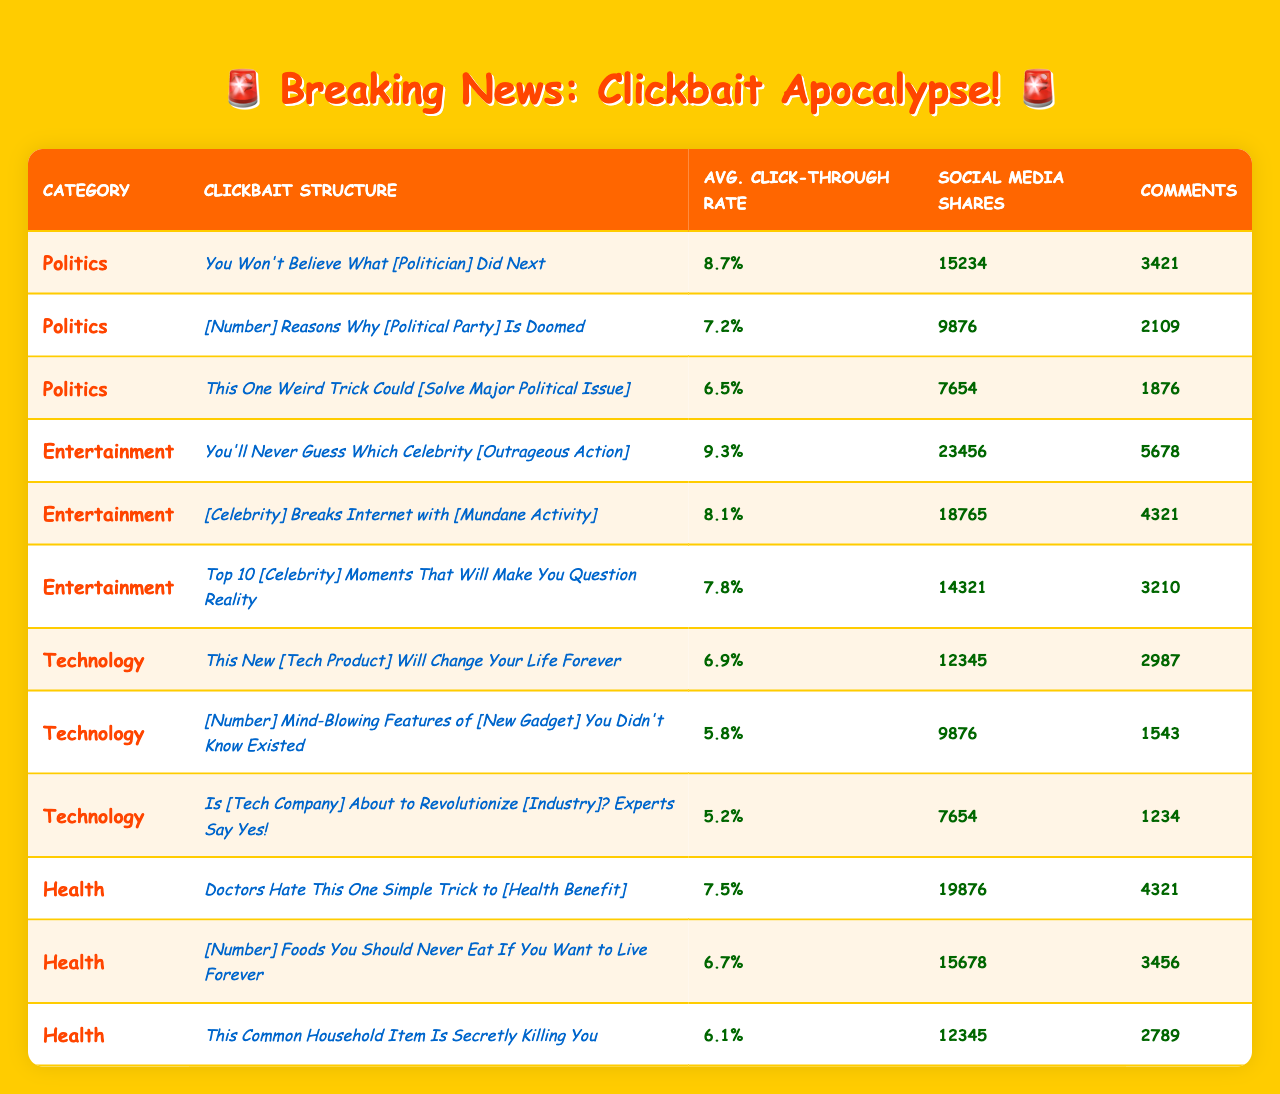What's the click-through rate of the clickbait structure "You Won't Believe What [Politician] Did Next"? The table shows that the click-through rate for this structure under the Politics category is 8.7%.
Answer: 8.7% Which news category has the highest average click-through rate? By comparing the average click-through rates across categories, Entertainment has the highest rate at 9.3%.
Answer: Entertainment How many social media shares did the clickbait structure "[Celebrity] Breaks Internet with [Mundane Activity]" receive? In the table, this structure has 18,765 social media shares listed.
Answer: 18,765 What is the average click-through rate across all categories? The average rates for each category are: Politics (8.7%), Entertainment (9.3%), Technology (6.9%), and Health (7.5%). Summing these gives 32.4%, and dividing by 4 categories gives an average of 8.1%.
Answer: 8.1% Is it true that the clickbait structure "This One Weird Trick Could [Solve Major Political Issue]" has more comments than the structure "Doctors Hate This One Simple Trick to [Health Benefit]"? The first structure has 1,876 comments while the second structure has 4,321 comments, making the statement false.
Answer: No Which clickbait structure in the Technology category has the lowest click-through rate? The table indicates that "Is [Tech Company] About to Revolutionize [Industry]? Experts Say Yes!" has the lowest click-through rate at 5.2%.
Answer: 5.2% What is the total number of comments for all clickbait structures in the Health category? The comments for the Health structures are 4,321 for the first, 3,456 for the second, and 2,789 for the third. The total is 4,321 + 3,456 + 2,789 = 10,566.
Answer: 10,566 Which clickbait structure has the most social media shares in the Politics category? The clickbait structure "You Won't Believe What [Politician] Did Next" has the highest social media shares at 15,234.
Answer: 15,234 What is the difference in click-through rates between the highest and lowest structures in the Entertainment category? The highest is 9.3% ("You'll Never Guess Which Celebrity [Outrageous Action]") and the lowest is 7.8% ("Top 10 [Celebrity] Moments That Will Make You Question Reality"). The difference is 9.3% - 7.8% = 1.5%.
Answer: 1.5% Does the "This New [Tech Product] Will Change Your Life Forever" structure perform better in terms of comments than the "Top 10 [Celebrity] Moments That Will Make You Question Reality"? The first structure has 2,987 comments while the latter has 3,210, meaning it does not perform better in terms of comments.
Answer: No 